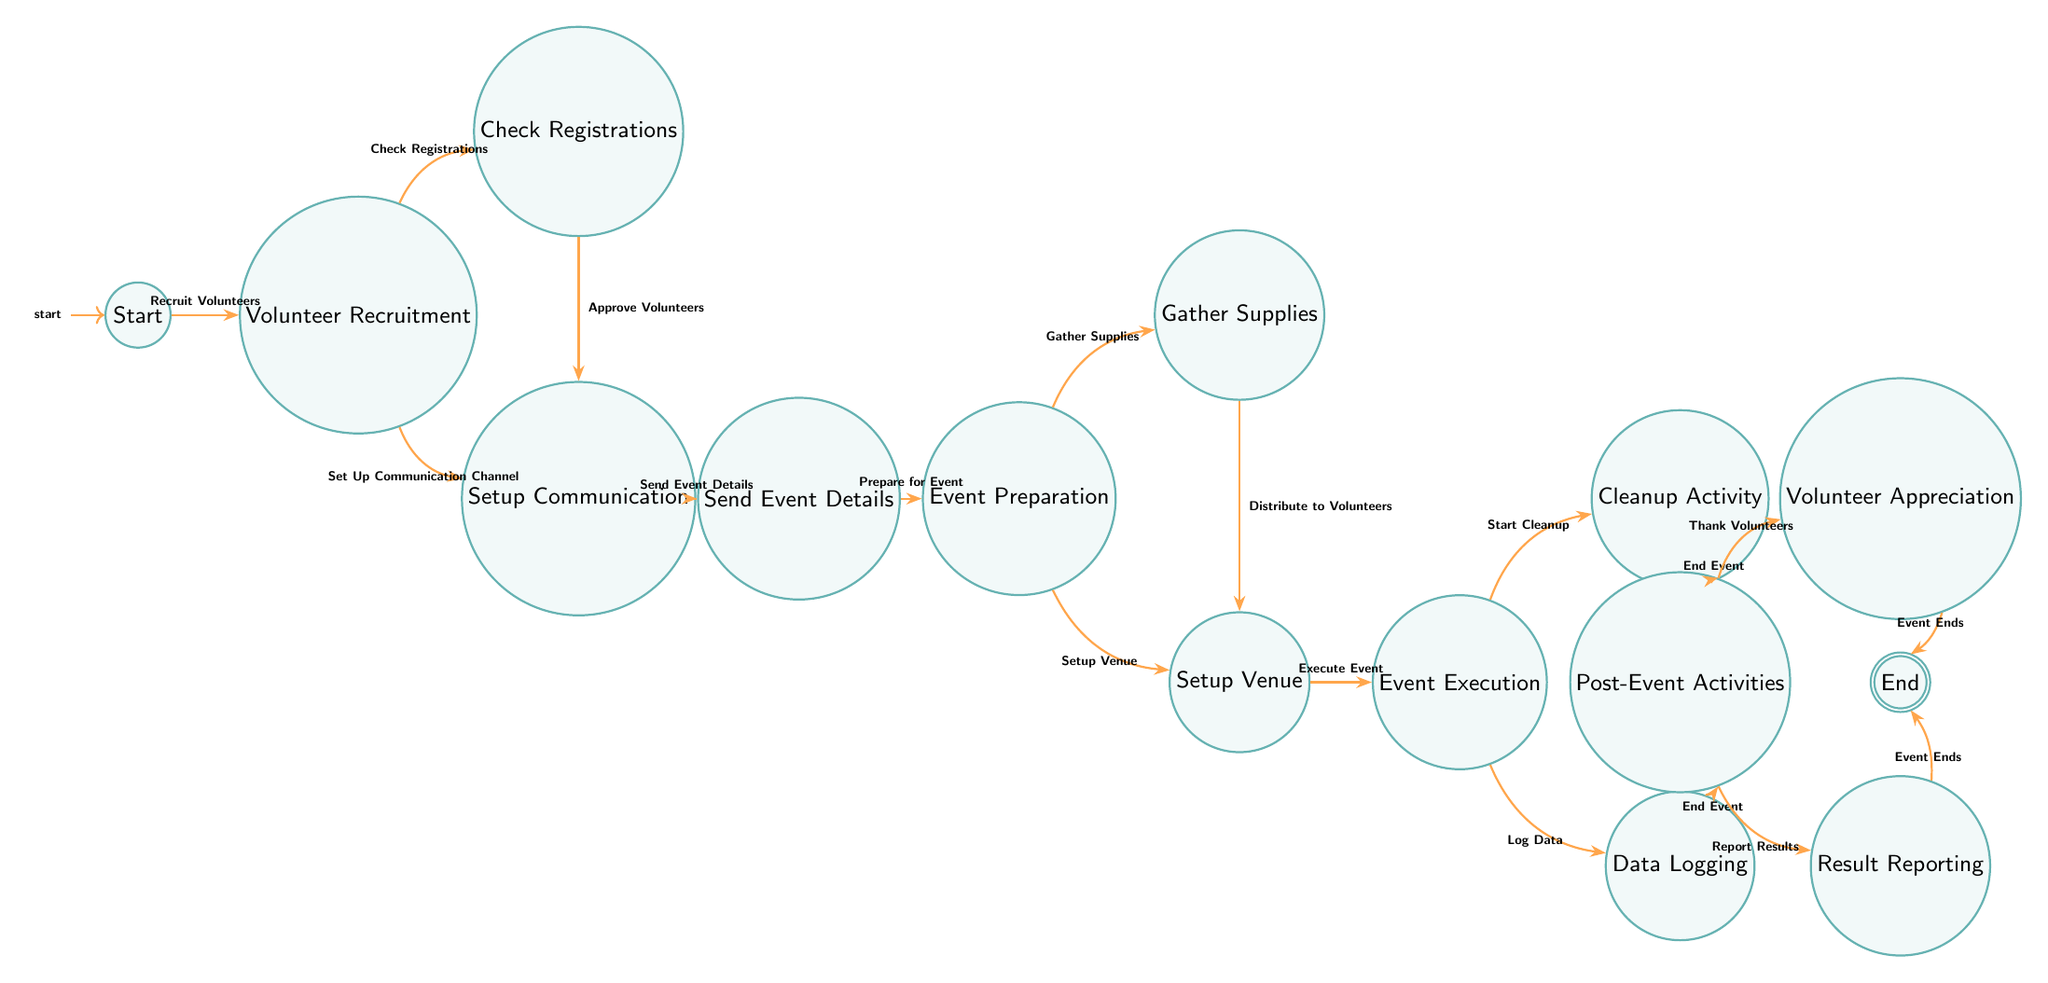What is the first action in the workflow? The first action in the workflow is "Recruit Volunteers," which is connected to the "Start" node and indicates where the process begins.
Answer: Recruit Volunteers How many total states are in the diagram? By counting all the unique nodes listed in the diagram, we determine there are a total of 14 states.
Answer: 14 Which state follows "Setup Communication"? According to the diagram, "Send Event Details" is the state that immediately follows "Setup Communication."
Answer: Send Event Details What action leads to "Event Execution"? The action that leads to "Event Execution" is "Execute Event," which is the transition from the "Setup Venue" state.
Answer: Execute Event What are the two actions that transition from "Post-Event Activities"? The two actions that transition from "Post-Event Activities" are "Thank Volunteers" and "Report Results," leading to their respective states.
Answer: Thank Volunteers, Report Results Which state is reached after "Cleanup Activity"? After "Cleanup Activity," the workflow transitions to "Post-Event Activities" when the action "End Event" is taken.
Answer: Post-Event Activities How do you go from "Check Registrations" to "Setup Communication"? You transition from "Check Registrations" to "Setup Communication" by taking the action "Approve Volunteers." This indicates that volunteers are confirmed and communication is set up next.
Answer: Approve Volunteers What is the final state in the diagram? The final state in the diagram is "End," which is reached after either "Volunteer Appreciation" or "Result Reporting" completes.
Answer: End What actions can occur simultaneously in the "Event Preparation" state? Two actions can occur simultaneously in "Event Preparation": "Gather Supplies" and "Setup Venue." This indicates the preparation phase can involve both tasks at once.
Answer: Gather Supplies, Setup Venue What state follows "Data Logging"? Following "Data Logging," the workflow transitions to "Post-Event Activities," as the action "End Event" is taken from either "Cleanup Activity" or "Data Logging."
Answer: Post-Event Activities 